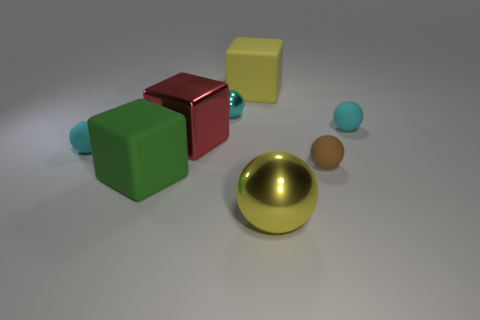Subtract all red blocks. How many cyan spheres are left? 3 Subtract all blue spheres. Subtract all red cylinders. How many spheres are left? 5 Add 1 tiny green matte objects. How many objects exist? 9 Subtract all blocks. How many objects are left? 5 Add 7 yellow rubber cubes. How many yellow rubber cubes exist? 8 Subtract 0 brown cubes. How many objects are left? 8 Subtract all big matte blocks. Subtract all large green matte blocks. How many objects are left? 5 Add 4 big spheres. How many big spheres are left? 5 